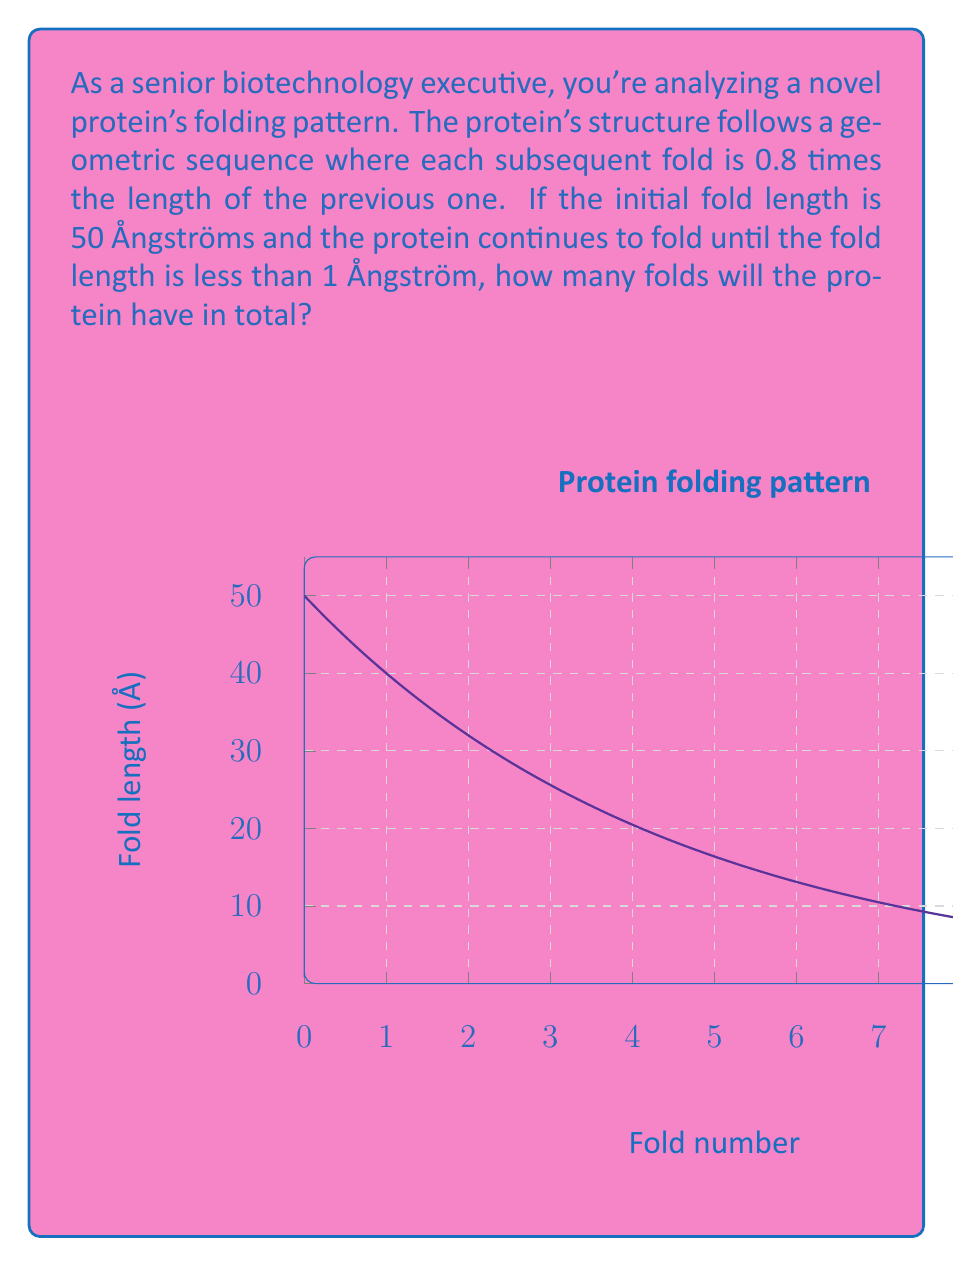Provide a solution to this math problem. Let's approach this step-by-step:

1) We have a geometric sequence with first term $a = 50$ Å and common ratio $r = 0.8$.

2) The general term of a geometric sequence is given by $a_n = ar^{n-1}$, where $n$ is the term number.

3) We need to find the largest $n$ for which $a_n \geq 1$ Å.

4) Let's set up the inequality:

   $ar^{n-1} \geq 1$

5) Substituting our values:

   $50 \cdot 0.8^{n-1} \geq 1$

6) Taking logarithms of both sides (base 0.8):

   $\log_{0.8}50 + (n-1) \geq \log_{0.8}1$

7) Simplify (note that $\log_{0.8}1 = 0$):

   $\log_{0.8}50 + n - 1 \geq 0$

8) Solve for $n$:

   $n \geq 1 - \log_{0.8}50$

9) Calculate:

   $n \geq 1 - \frac{\ln 50}{\ln 0.8} \approx 10.4$

10) Since $n$ must be an integer, and we want the largest $n$ that satisfies the inequality, we round down to 10.

Therefore, there will be 10 folds in total.
Answer: 10 folds 